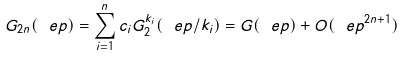<formula> <loc_0><loc_0><loc_500><loc_500>G _ { 2 n } ( \ e p ) = \sum _ { i = 1 } ^ { n } c _ { i } G _ { 2 } ^ { k _ { i } } ( \ e p / k _ { i } ) = G ( \ e p ) + O ( \ e p ^ { 2 n + 1 } )</formula> 